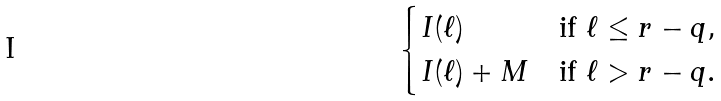<formula> <loc_0><loc_0><loc_500><loc_500>\begin{cases} I ( \ell ) & \text {if } \ell \leq r - q , \\ I ( \ell ) + M & \text {if } \ell > r - q . \end{cases}</formula> 